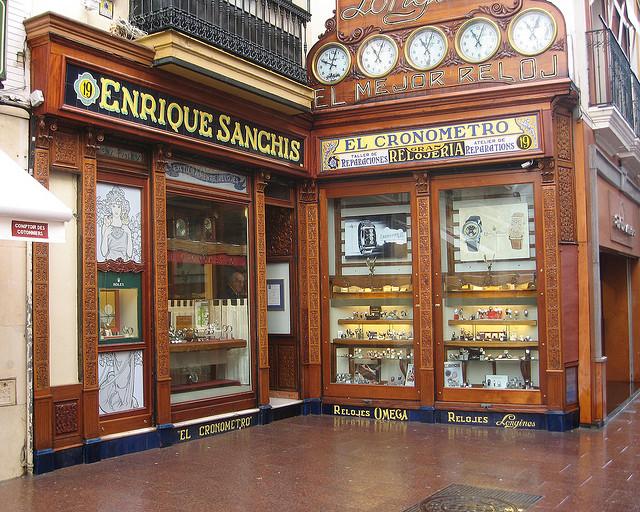What are the clocks encased in?
Quick response, please. Glass. How many clocks are there?
Keep it brief. 5. What type of shop is this?
Concise answer only. Perfume. What color is the trim at the bottom of the display?
Quick response, please. Blue. 